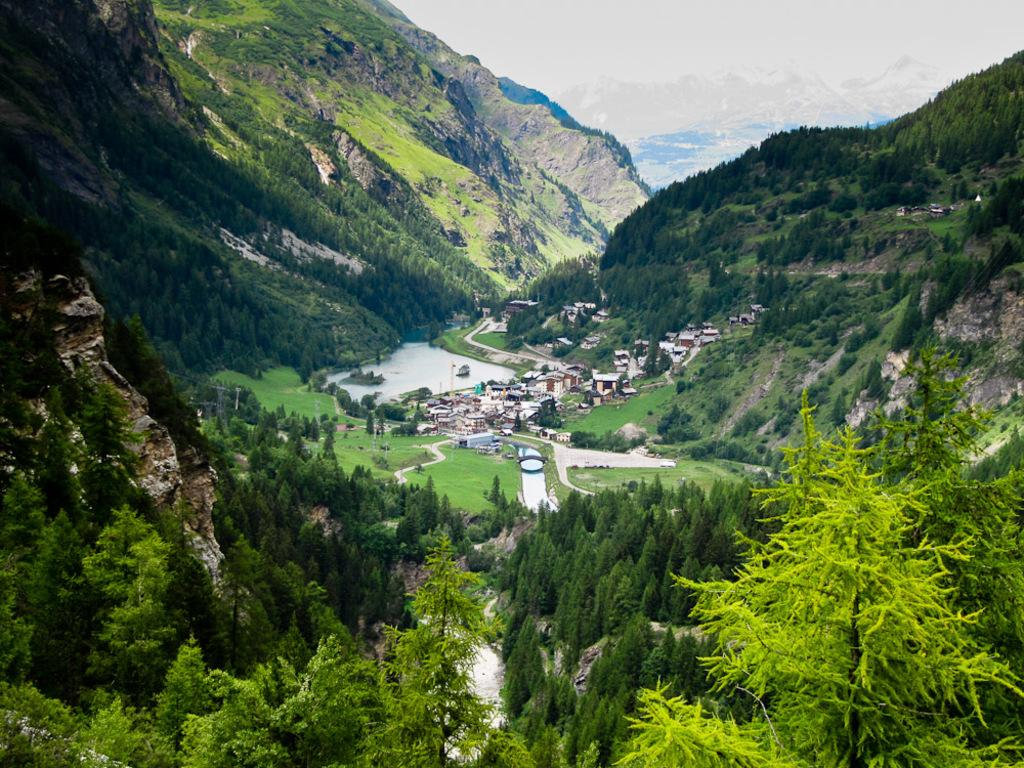What can be seen in the sky in the image? There is sky visible in the image. What type of natural landforms are present in the image? There are mountains and hills in the image. What type of vegetation is present in the image? There are trees in the image. What type of water feature can be seen in the image? There is water visible in the image. What type of man-made structures are present in the image? There are buildings in the image. How many icicles are hanging from the trees in the image? There are no icicles present in the image, as it does not depict a winter scene or freezing temperatures. What type of health advice is being given in the image? There is no health advice present in the image; it features natural and man-made elements in a landscape. 